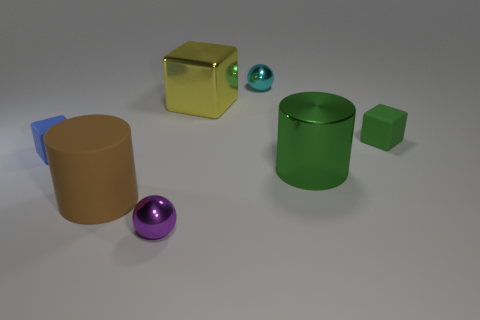Subtract all rubber cubes. How many cubes are left? 1 Add 1 green shiny objects. How many objects exist? 8 Subtract 1 balls. How many balls are left? 1 Subtract all purple balls. How many balls are left? 1 Subtract 0 blue spheres. How many objects are left? 7 Subtract all blocks. How many objects are left? 4 Subtract all red cylinders. Subtract all red blocks. How many cylinders are left? 2 Subtract all cyan balls. How many green cylinders are left? 1 Subtract all red matte cylinders. Subtract all rubber cylinders. How many objects are left? 6 Add 2 metal balls. How many metal balls are left? 4 